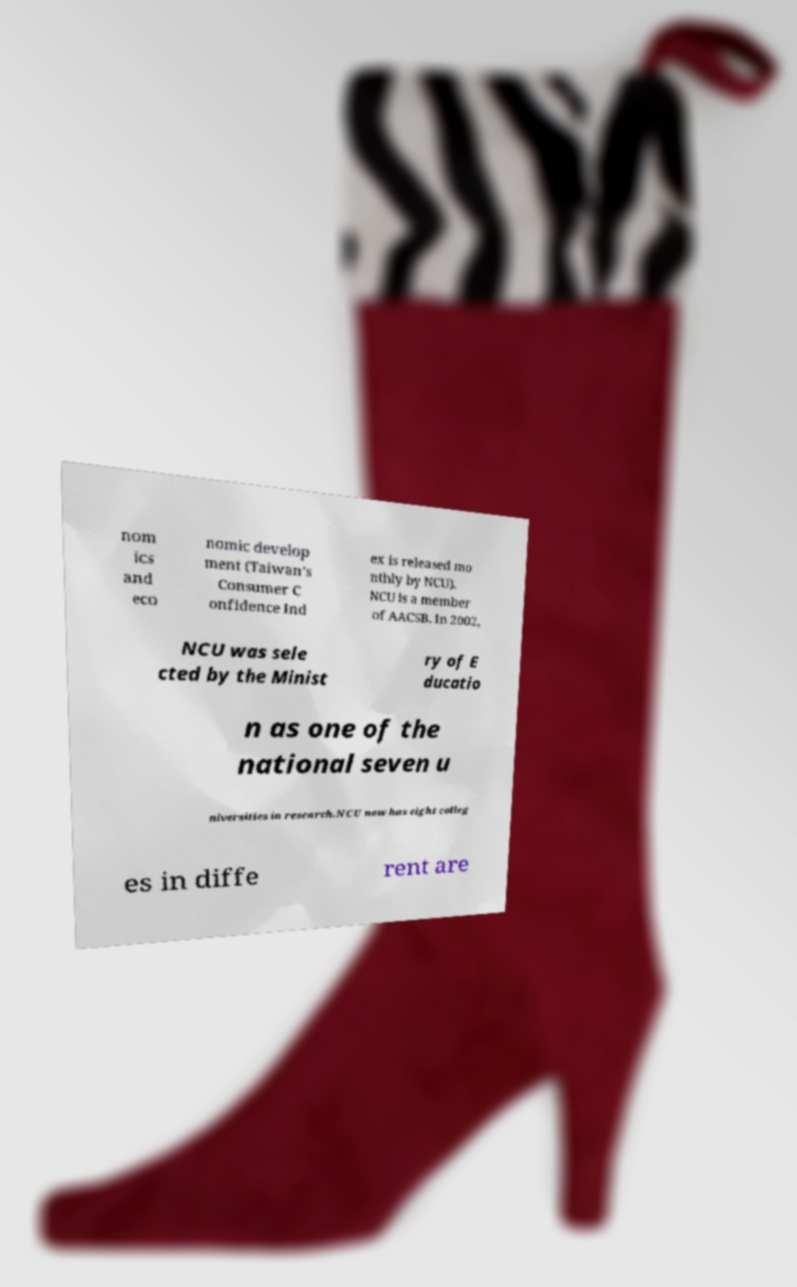Could you extract and type out the text from this image? nom ics and eco nomic develop ment (Taiwan's Consumer C onfidence Ind ex is released mo nthly by NCU). NCU is a member of AACSB. In 2002, NCU was sele cted by the Minist ry of E ducatio n as one of the national seven u niversities in research.NCU now has eight colleg es in diffe rent are 